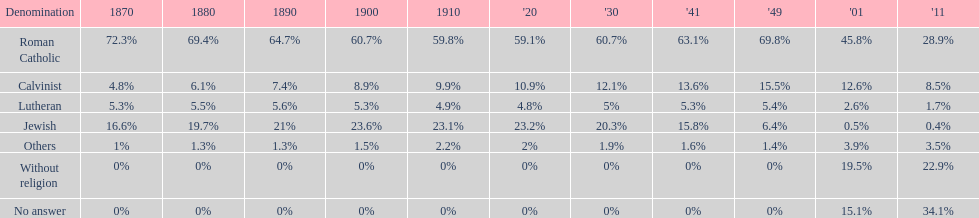Which denomination percentage increased the most after 1949? Without religion. 